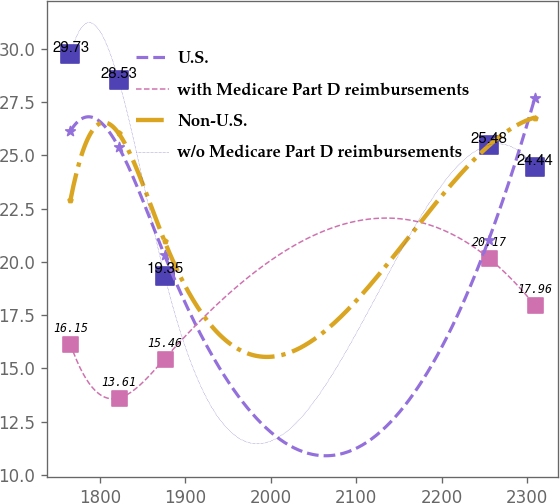Convert chart to OTSL. <chart><loc_0><loc_0><loc_500><loc_500><line_chart><ecel><fcel>U.S.<fcel>with Medicare Part D reimbursements<fcel>Non-U.S.<fcel>w/o Medicare Part D reimbursements<nl><fcel>1765.58<fcel>26.13<fcel>16.15<fcel>22.88<fcel>29.73<nl><fcel>1822<fcel>25.39<fcel>13.61<fcel>26.03<fcel>28.53<nl><fcel>1875.83<fcel>20.3<fcel>15.46<fcel>20.96<fcel>19.35<nl><fcel>2254.88<fcel>21.04<fcel>20.17<fcel>25.45<fcel>25.48<nl><fcel>2308.71<fcel>27.68<fcel>17.96<fcel>26.77<fcel>24.44<nl></chart> 